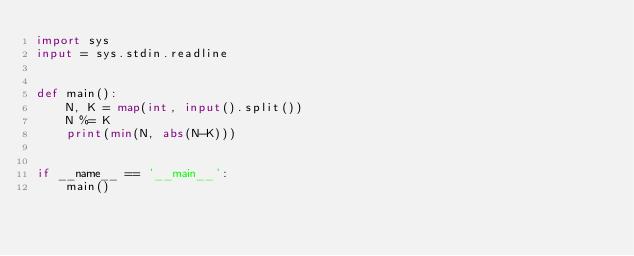<code> <loc_0><loc_0><loc_500><loc_500><_Python_>import sys
input = sys.stdin.readline


def main():
    N, K = map(int, input().split())
    N %= K
    print(min(N, abs(N-K)))


if __name__ == '__main__':
    main()
</code> 